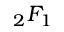Convert formula to latex. <formula><loc_0><loc_0><loc_500><loc_500>{ } _ { 2 } F _ { 1 }</formula> 